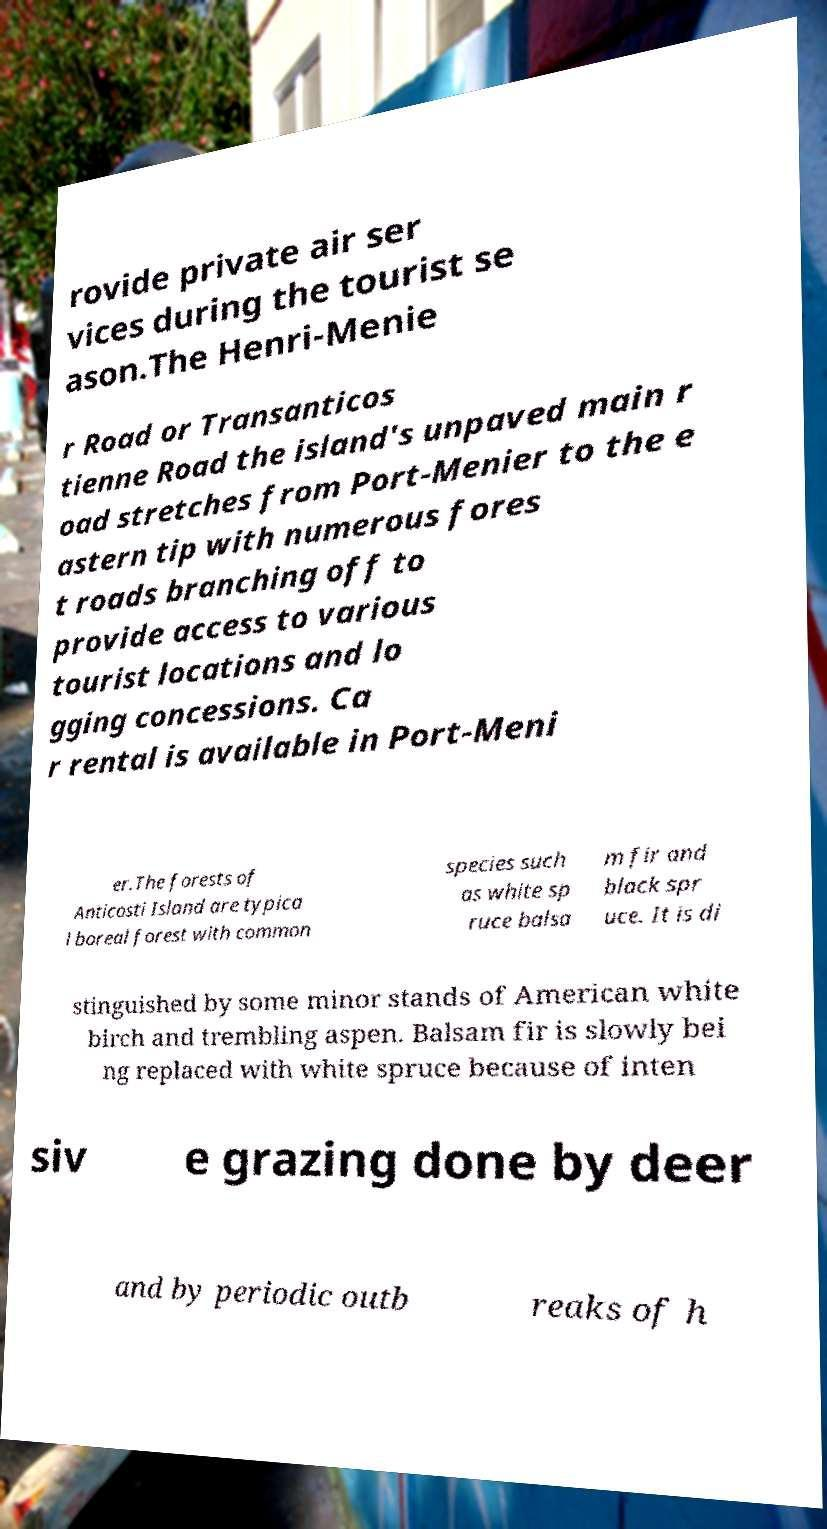There's text embedded in this image that I need extracted. Can you transcribe it verbatim? rovide private air ser vices during the tourist se ason.The Henri-Menie r Road or Transanticos tienne Road the island's unpaved main r oad stretches from Port-Menier to the e astern tip with numerous fores t roads branching off to provide access to various tourist locations and lo gging concessions. Ca r rental is available in Port-Meni er.The forests of Anticosti Island are typica l boreal forest with common species such as white sp ruce balsa m fir and black spr uce. It is di stinguished by some minor stands of American white birch and trembling aspen. Balsam fir is slowly bei ng replaced with white spruce because of inten siv e grazing done by deer and by periodic outb reaks of h 